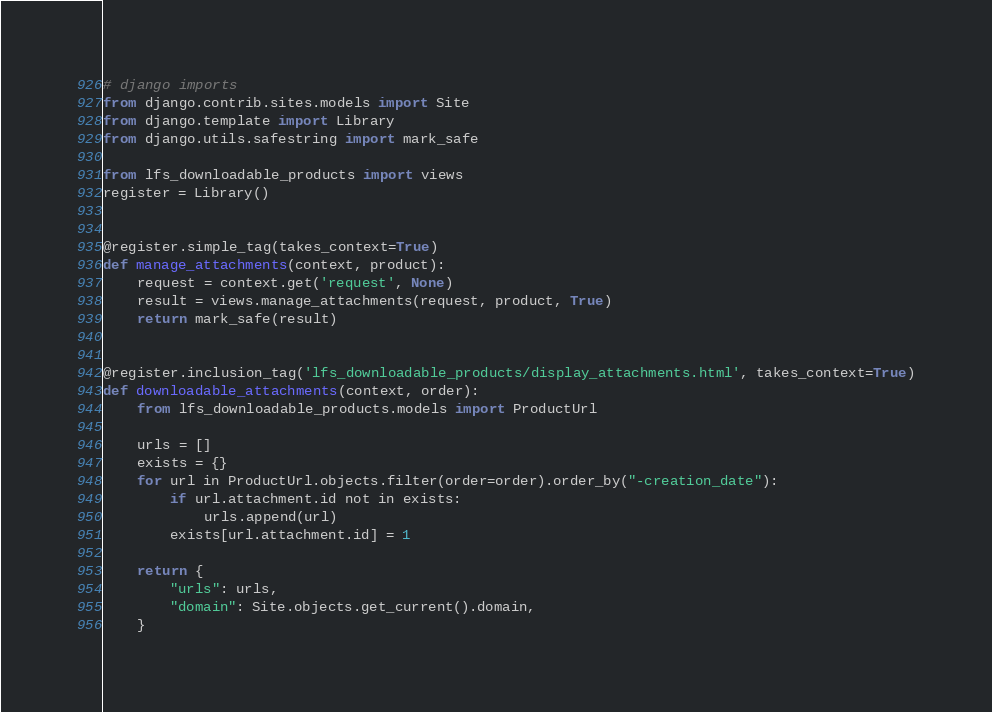<code> <loc_0><loc_0><loc_500><loc_500><_Python_># django imports
from django.contrib.sites.models import Site
from django.template import Library
from django.utils.safestring import mark_safe

from lfs_downloadable_products import views
register = Library()


@register.simple_tag(takes_context=True)
def manage_attachments(context, product):
    request = context.get('request', None)
    result = views.manage_attachments(request, product, True)
    return mark_safe(result)


@register.inclusion_tag('lfs_downloadable_products/display_attachments.html', takes_context=True)
def downloadable_attachments(context, order):
    from lfs_downloadable_products.models import ProductUrl

    urls = []
    exists = {}
    for url in ProductUrl.objects.filter(order=order).order_by("-creation_date"):
        if url.attachment.id not in exists:
            urls.append(url)
        exists[url.attachment.id] = 1

    return {
        "urls": urls,
        "domain": Site.objects.get_current().domain,
    }
</code> 